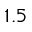<formula> <loc_0><loc_0><loc_500><loc_500>1 . 5</formula> 